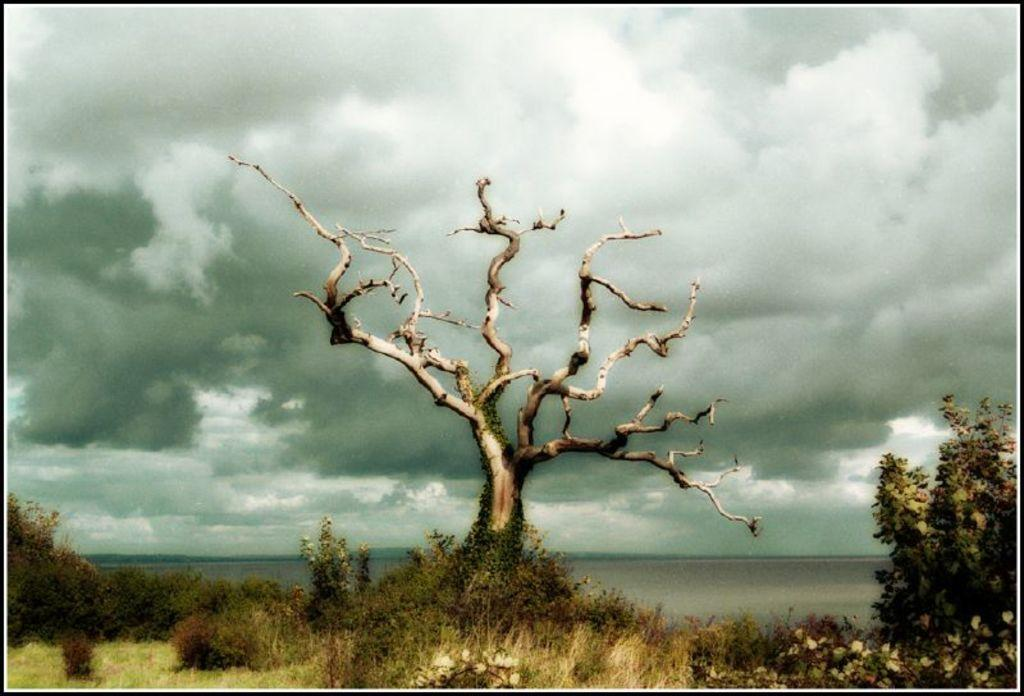What type of vegetation can be seen in the image? There are plants and trees in the image. What part of the natural environment is visible in the image? The sky is visible in the image. How would you describe the sky in the image? The sky is cloudy in the image. What type of furniture can be seen in the aftermath of the image? There is no furniture present in the image, and there is no mention of an aftermath. 